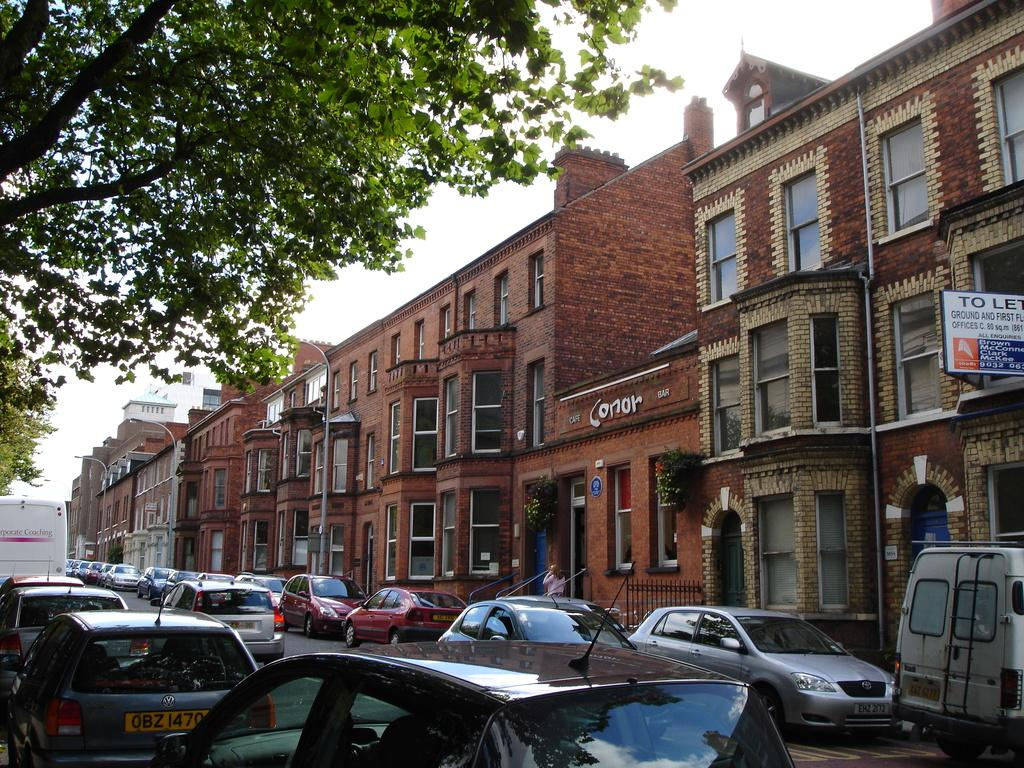<image>
Offer a succinct explanation of the picture presented. A bar called conor bar is in between two buildings that are taller than it is. 